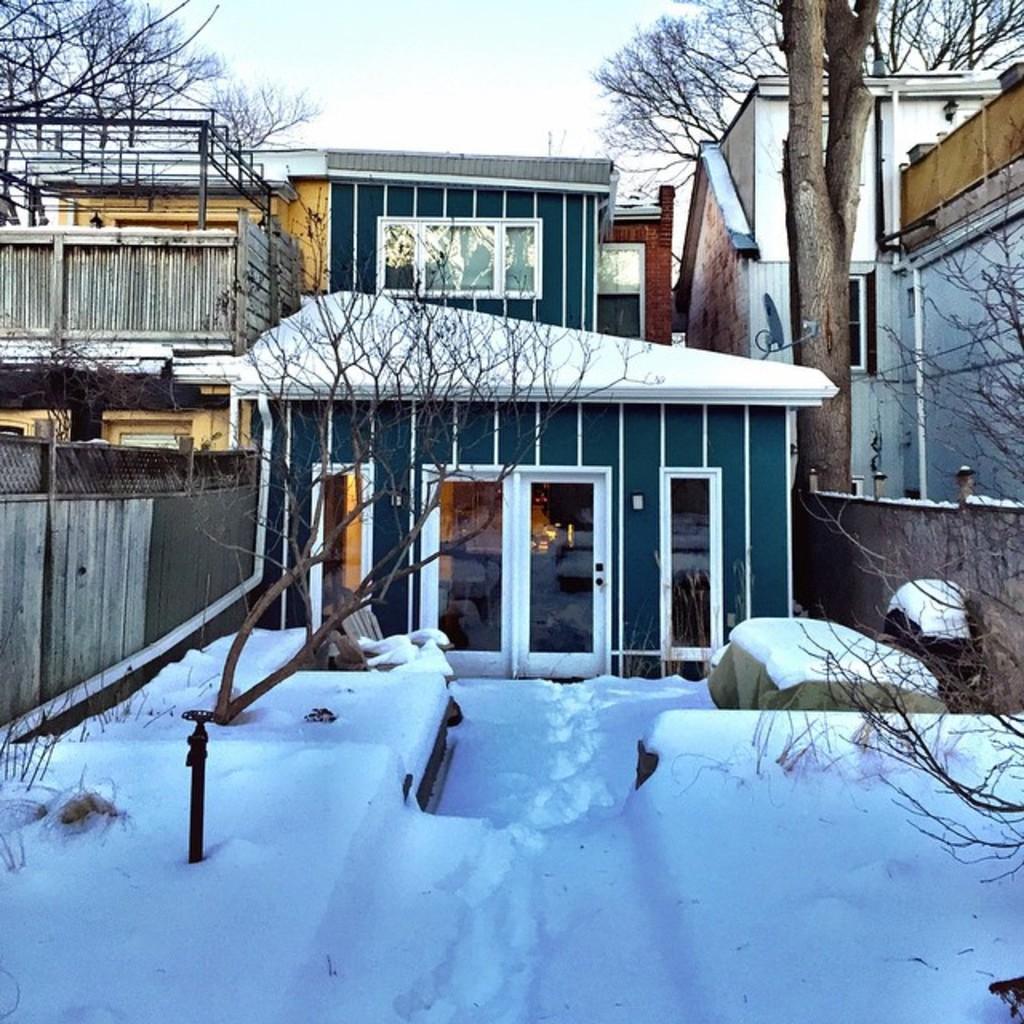Could you give a brief overview of what you see in this image? In this picture I can see many buildings. In front of the door I can see the snow, stone and trees. At the top I can see the sky and clouds. On the right I can see the fencing and wooden partition. 